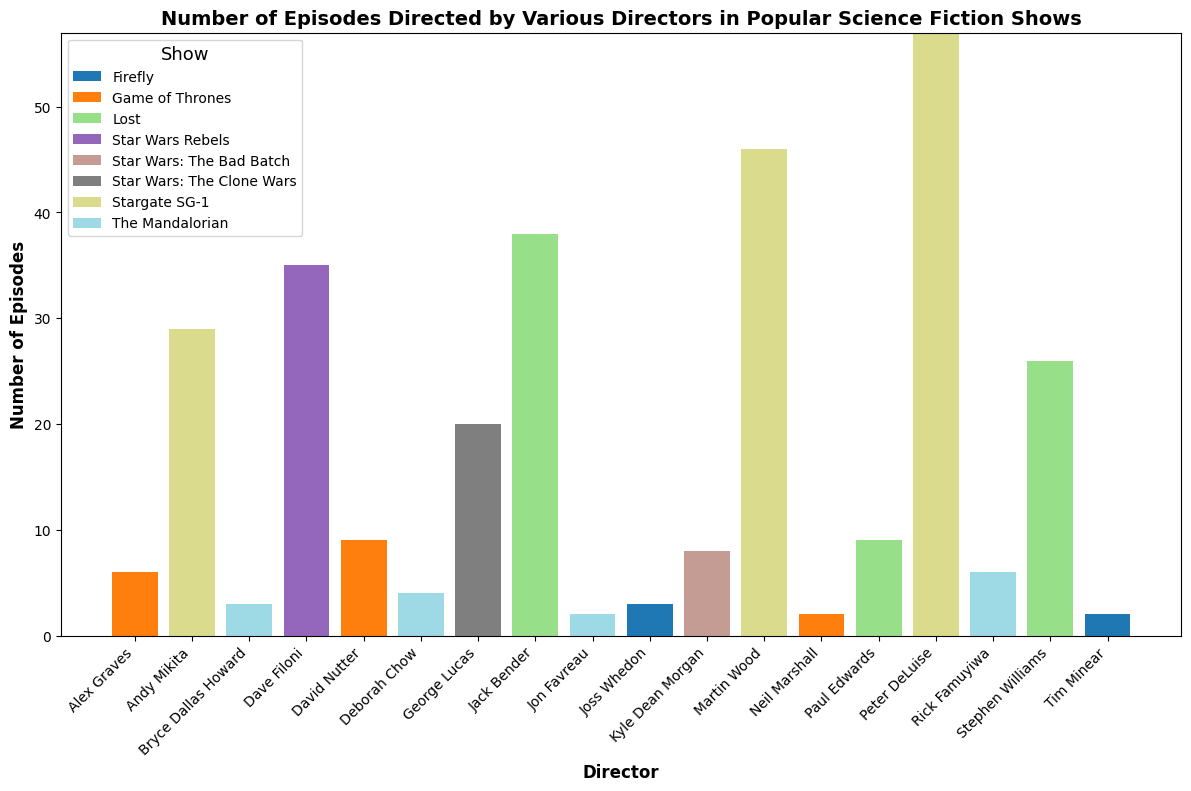what's the total number of episodes directed by Dave Filoni and Bryce Dallas Howard? Dave Filoni directed 35 episodes and Bryce Dallas Howard directed 3 episodes. Adding these (35 + 3) results in a total of 38 episodes.
Answer: 38 Which director has directed the most episodes for "Lost"? By observing the figure, Jack Bender directed the most episodes for "Lost" with a total of 38 episodes.
Answer: Jack Bender Comparing "Stargate SG-1" directors, who has directed more episodes: Peter DeLuise or Martin Wood? Peter DeLuise directed 57 episodes while Martin Wood directed 46 episodes. Comparing these, Peter DeLuise has directed more episodes.
Answer: Peter DeLuise What's the difference in the number of episodes directed by George Lucas and Rick Famuyiwa? George Lucas directed 20 episodes and Rick Famuyiwa directed 6 episodes. Taking the difference (20 - 6) gives us 14 episodes.
Answer: 14 What's the average number of episodes directed by the three directors of "The Mandalorian"? The three directors, Rick Famuyiwa, Deborah Chow, and Bryce Dallas Howard, directed 6, 4, and 3 episodes respectively. Adding these (6 + 4 + 3 = 13) and then dividing by 3 gives an average of 13/3 = 4.33 episodes.
Answer: 4.33 Which show has the most diversity in terms of the number of different directors? "Lost" has three directors: Jack Bender, Stephen Williams, and Paul Edwards. Observing the chart, it appears to have the highest diversity among directors compared to other shows.
Answer: Lost In terms of visual height, which bar is the tallest in the entire figure? The bar representing Peter DeLuise's episodes for "Stargate SG-1" is visually the tallest, as he directed 57 episodes.
Answer: Peter DeLuise for Stargate SG-1 By how much does Joss Whedon's contribution to "Firefly" exceed Tim Minear's? Joss Whedon directed 3 episodes while Tim Minear directed 2 episodes. The difference between their contributions is 3 - 2 = 1 episode.
Answer: 1 